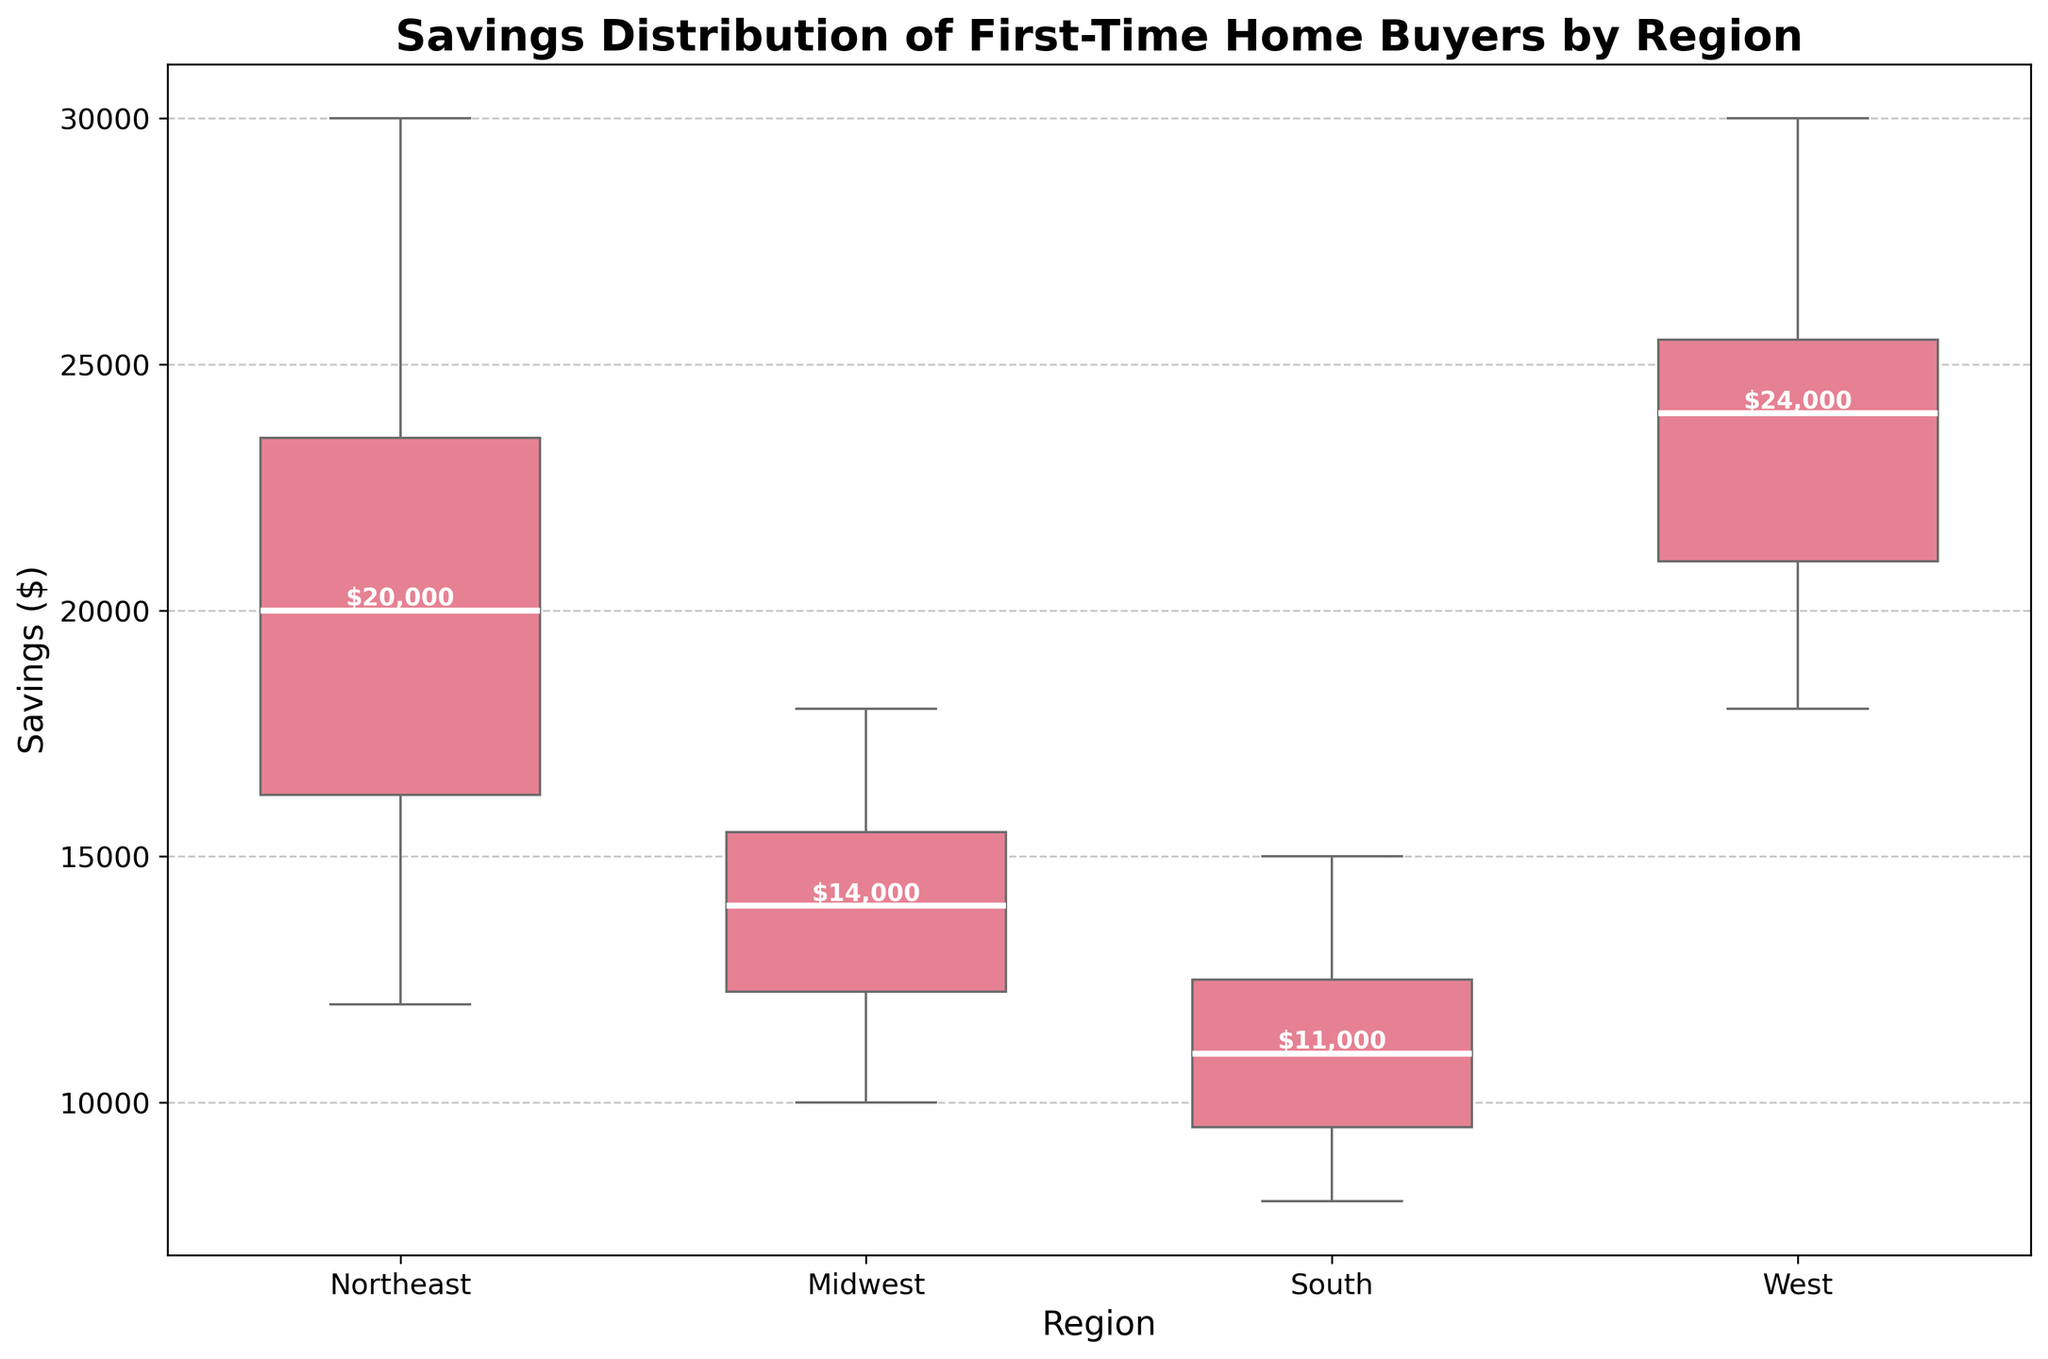What's the title of the figure? The title of the figure is located at the top and provides an overview of what the figure is about.
Answer: Savings Distribution of First-Time Home Buyers by Region Which region has the highest median savings value? The white line inside each boxplot represents the median savings. The region with the highest white line is the one with the highest median savings value.
Answer: West What is the range of savings values for the Northeast region? The range is determined by the bottom and top lines of the box for the Northeast region, which represent the minimum and maximum values excluding outliers.
Answer: $12,000 to $30,000 Which region has the lowest median savings value? By identifying the region with the lowest white line in its boxplot, we can determine which region has the lowest median savings value.
Answer: South What is the interquartile range (IQR) for the Midwest region? The IQR is the difference between the upper quartile (top of the box) and the lower quartile (bottom of the box). For the Midwest region, this is calculated using these two values from its boxplot.
Answer: $10,000 to $18,000 How do the savings distributions in the South and Midwest regions compare to each other? By comparing the positions and spreads of the boxes and whiskers of the South and Midwest regions, we can determine the differences in their distributions.
Answer: The Midwest region has a higher median and broader savings range compared to the South Which region shows the greatest spread in savings values? The region with the widest box length combined with the whiskers indicates the greatest spread in savings values.
Answer: Northeast Are there any notable outliers in any region? In a boxplot, notable outliers are indicated by points outside of the whiskers.
Answer: No What is the median savings value for the Northeast region? The median is represented by the white line within the box of the Northeast region. Refer to the white label inside the Northeast box.
Answer: $22,000 How does the median savings in the West compare to the Northeast? By locating the white lines in both the West and Northeast boxes, we can compare their medians.
Answer: The median savings is higher in the West than in the Northeast 